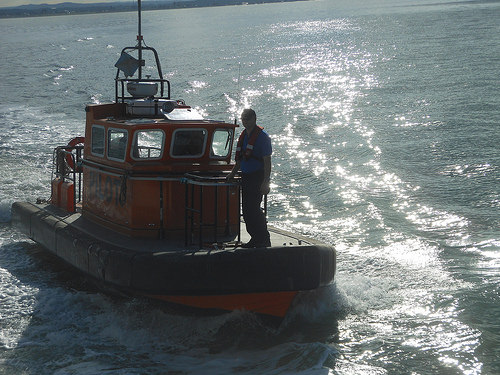<image>
Is the sun on the water? Yes. Looking at the image, I can see the sun is positioned on top of the water, with the water providing support. 